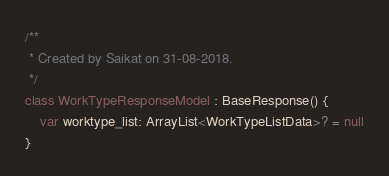Convert code to text. <code><loc_0><loc_0><loc_500><loc_500><_Kotlin_>

/**
 * Created by Saikat on 31-08-2018.
 */
class WorkTypeResponseModel : BaseResponse() {
    var worktype_list: ArrayList<WorkTypeListData>? = null
}</code> 